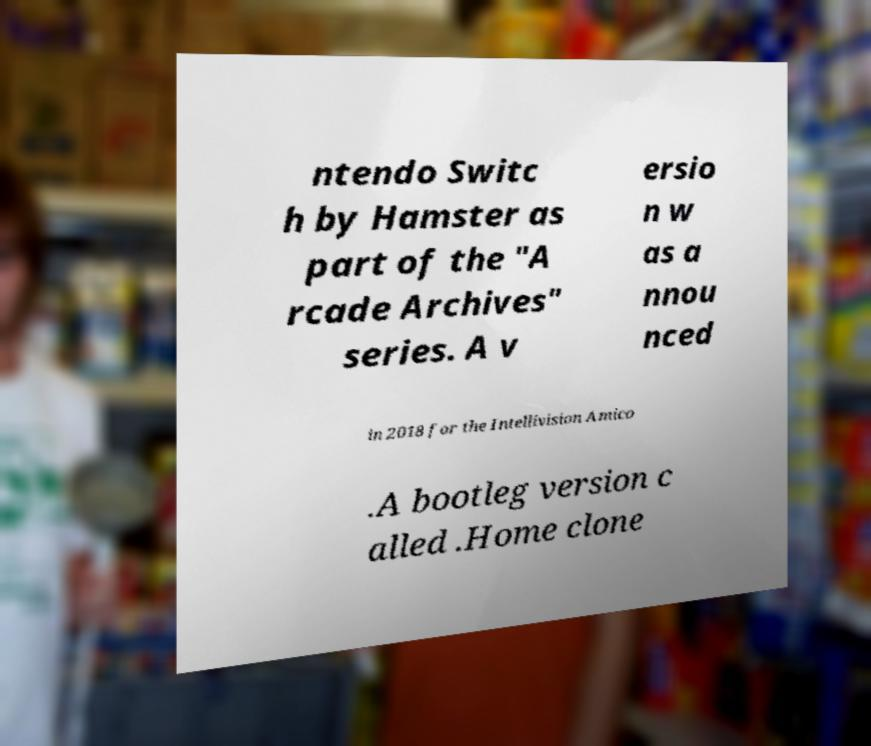Could you assist in decoding the text presented in this image and type it out clearly? ntendo Switc h by Hamster as part of the "A rcade Archives" series. A v ersio n w as a nnou nced in 2018 for the Intellivision Amico .A bootleg version c alled .Home clone 